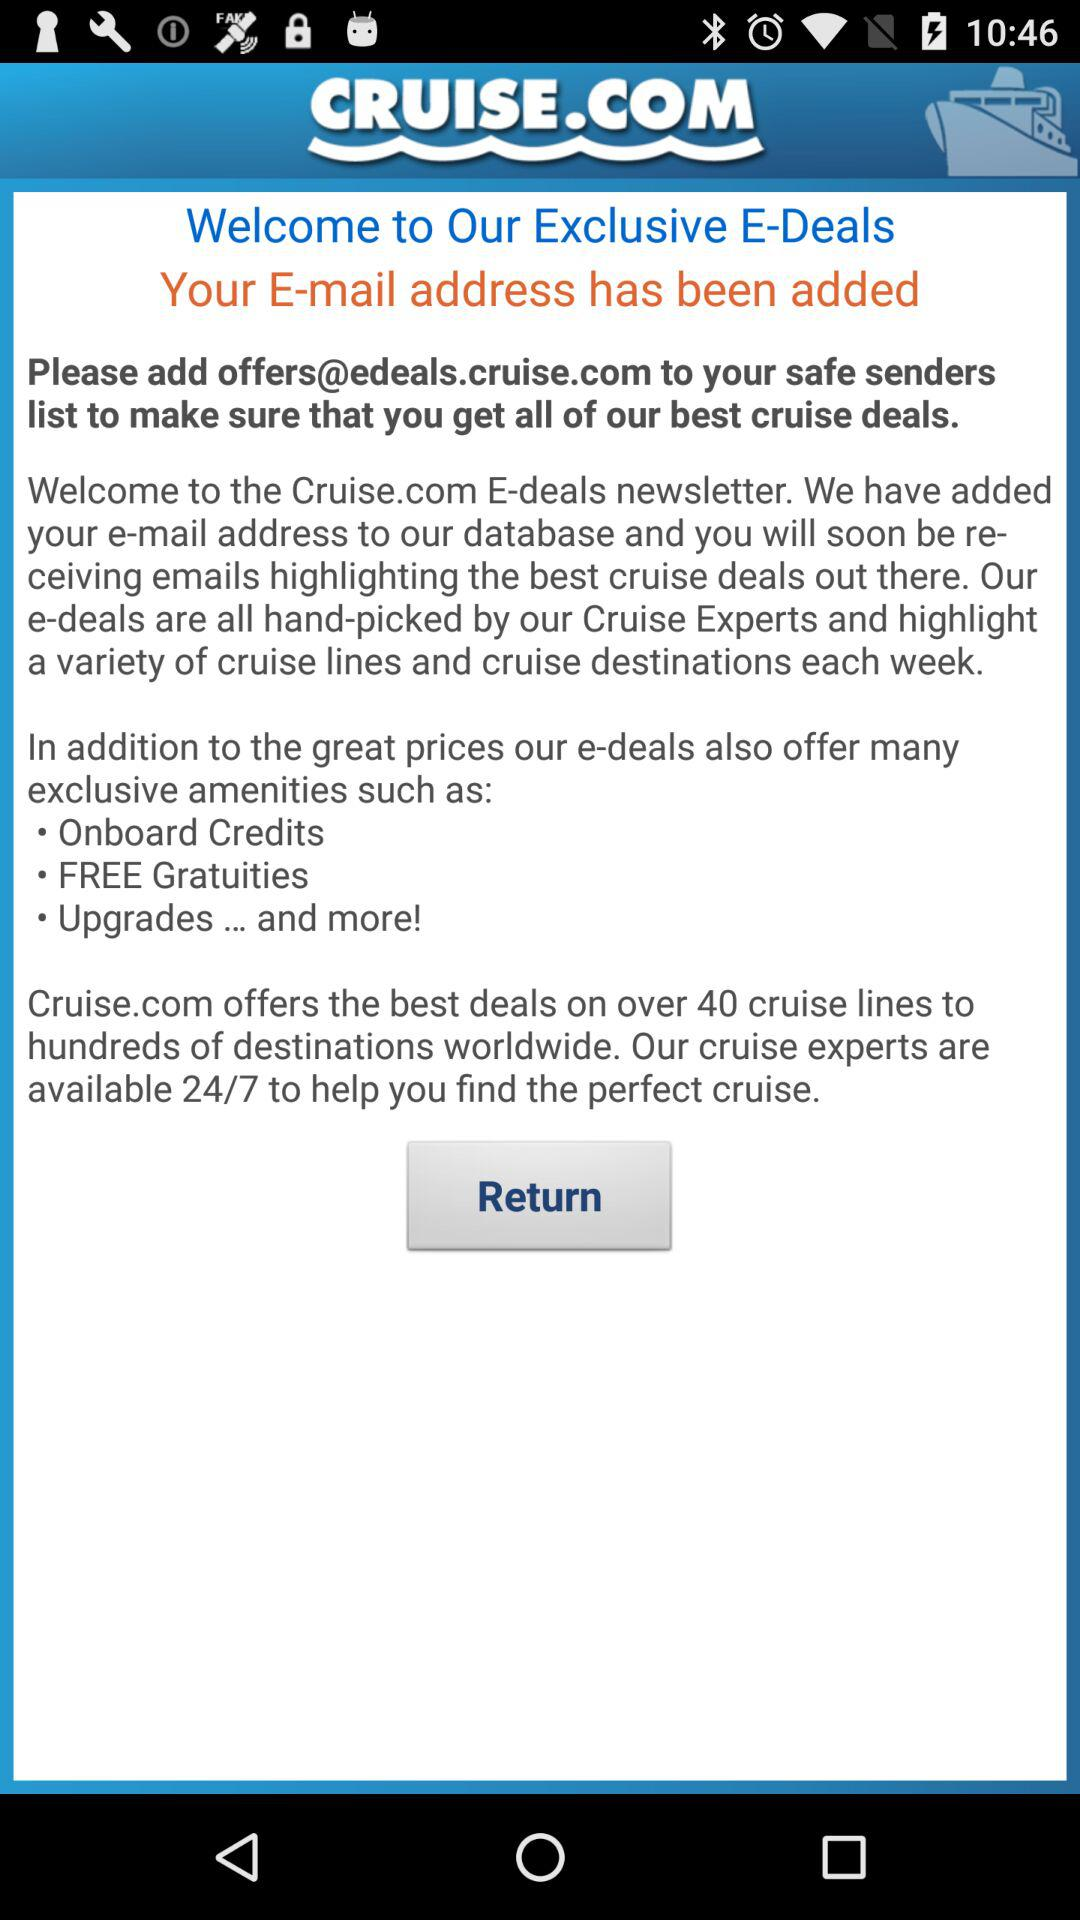How many cruise lines does Cruise.com offer deals on? Cruise.com offers deals on over 40 cruise lines. 